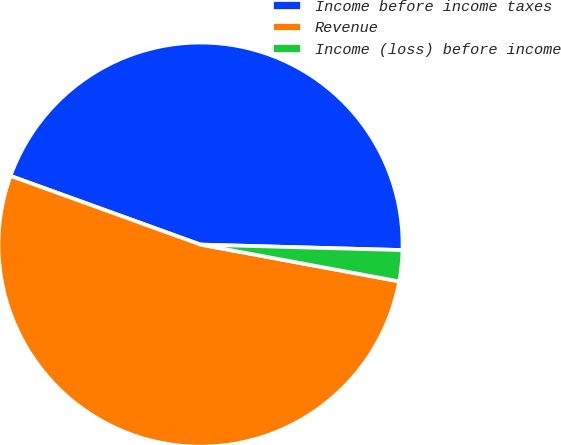Convert chart to OTSL. <chart><loc_0><loc_0><loc_500><loc_500><pie_chart><fcel>Income before income taxes<fcel>Revenue<fcel>Income (loss) before income<nl><fcel>44.91%<fcel>52.61%<fcel>2.48%<nl></chart> 